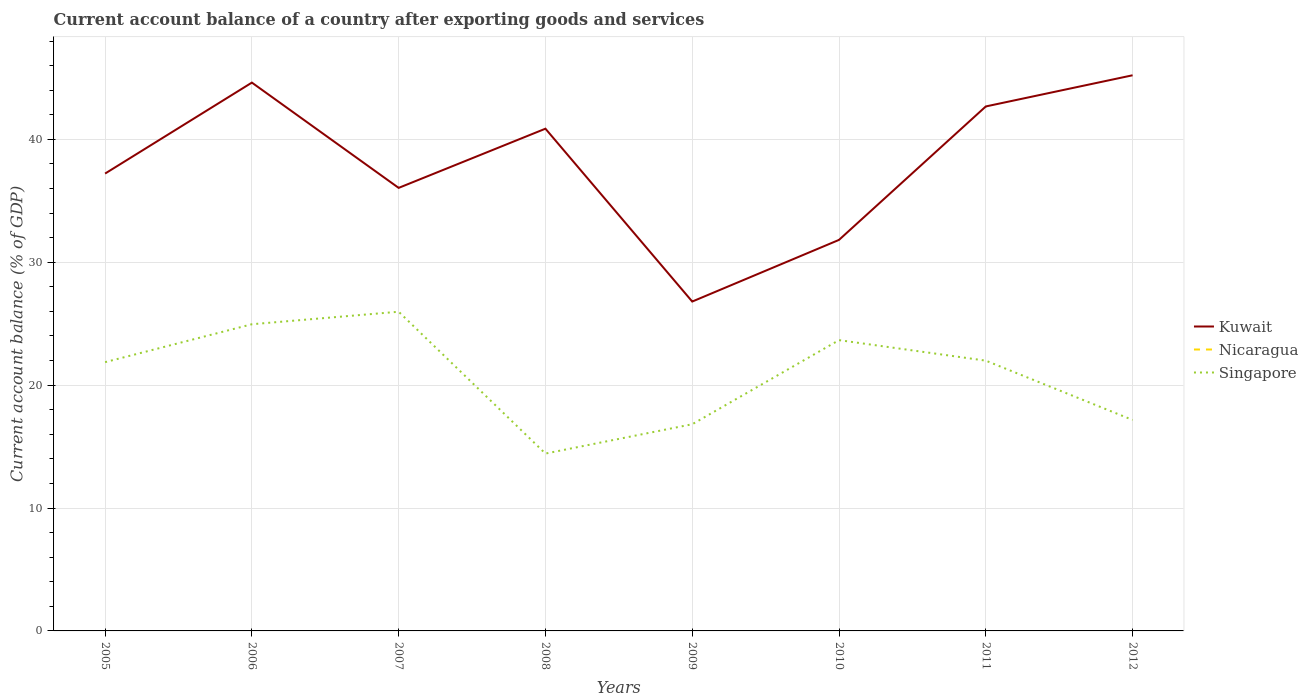How many different coloured lines are there?
Your response must be concise. 2. Does the line corresponding to Kuwait intersect with the line corresponding to Singapore?
Your answer should be very brief. No. Across all years, what is the maximum account balance in Singapore?
Provide a short and direct response. 14.43. What is the total account balance in Kuwait in the graph?
Your answer should be compact. -7.4. What is the difference between the highest and the second highest account balance in Singapore?
Give a very brief answer. 11.54. What is the difference between the highest and the lowest account balance in Kuwait?
Provide a succinct answer. 4. Does the graph contain grids?
Your answer should be compact. Yes. Where does the legend appear in the graph?
Offer a terse response. Center right. How many legend labels are there?
Provide a short and direct response. 3. What is the title of the graph?
Make the answer very short. Current account balance of a country after exporting goods and services. Does "Least developed countries" appear as one of the legend labels in the graph?
Provide a short and direct response. No. What is the label or title of the X-axis?
Your answer should be very brief. Years. What is the label or title of the Y-axis?
Make the answer very short. Current account balance (% of GDP). What is the Current account balance (% of GDP) in Kuwait in 2005?
Provide a succinct answer. 37.22. What is the Current account balance (% of GDP) in Nicaragua in 2005?
Give a very brief answer. 0. What is the Current account balance (% of GDP) of Singapore in 2005?
Offer a very short reply. 21.87. What is the Current account balance (% of GDP) of Kuwait in 2006?
Offer a terse response. 44.62. What is the Current account balance (% of GDP) of Singapore in 2006?
Offer a very short reply. 24.96. What is the Current account balance (% of GDP) in Kuwait in 2007?
Offer a terse response. 36.05. What is the Current account balance (% of GDP) in Singapore in 2007?
Your answer should be very brief. 25.97. What is the Current account balance (% of GDP) in Kuwait in 2008?
Keep it short and to the point. 40.87. What is the Current account balance (% of GDP) in Nicaragua in 2008?
Make the answer very short. 0. What is the Current account balance (% of GDP) in Singapore in 2008?
Ensure brevity in your answer.  14.43. What is the Current account balance (% of GDP) in Kuwait in 2009?
Provide a short and direct response. 26.8. What is the Current account balance (% of GDP) in Nicaragua in 2009?
Keep it short and to the point. 0. What is the Current account balance (% of GDP) in Singapore in 2009?
Ensure brevity in your answer.  16.82. What is the Current account balance (% of GDP) of Kuwait in 2010?
Your response must be concise. 31.82. What is the Current account balance (% of GDP) in Singapore in 2010?
Give a very brief answer. 23.66. What is the Current account balance (% of GDP) in Kuwait in 2011?
Your response must be concise. 42.68. What is the Current account balance (% of GDP) in Singapore in 2011?
Offer a terse response. 21.99. What is the Current account balance (% of GDP) in Kuwait in 2012?
Your response must be concise. 45.22. What is the Current account balance (% of GDP) in Nicaragua in 2012?
Keep it short and to the point. 0. What is the Current account balance (% of GDP) of Singapore in 2012?
Provide a succinct answer. 17.17. Across all years, what is the maximum Current account balance (% of GDP) of Kuwait?
Provide a short and direct response. 45.22. Across all years, what is the maximum Current account balance (% of GDP) in Singapore?
Make the answer very short. 25.97. Across all years, what is the minimum Current account balance (% of GDP) of Kuwait?
Offer a very short reply. 26.8. Across all years, what is the minimum Current account balance (% of GDP) in Singapore?
Provide a short and direct response. 14.43. What is the total Current account balance (% of GDP) in Kuwait in the graph?
Your answer should be compact. 305.28. What is the total Current account balance (% of GDP) in Singapore in the graph?
Your answer should be compact. 166.87. What is the difference between the Current account balance (% of GDP) of Kuwait in 2005 and that in 2006?
Make the answer very short. -7.4. What is the difference between the Current account balance (% of GDP) of Singapore in 2005 and that in 2006?
Your answer should be compact. -3.08. What is the difference between the Current account balance (% of GDP) of Kuwait in 2005 and that in 2007?
Make the answer very short. 1.17. What is the difference between the Current account balance (% of GDP) of Singapore in 2005 and that in 2007?
Offer a very short reply. -4.1. What is the difference between the Current account balance (% of GDP) of Kuwait in 2005 and that in 2008?
Your response must be concise. -3.65. What is the difference between the Current account balance (% of GDP) in Singapore in 2005 and that in 2008?
Keep it short and to the point. 7.44. What is the difference between the Current account balance (% of GDP) in Kuwait in 2005 and that in 2009?
Offer a very short reply. 10.41. What is the difference between the Current account balance (% of GDP) of Singapore in 2005 and that in 2009?
Make the answer very short. 5.05. What is the difference between the Current account balance (% of GDP) of Kuwait in 2005 and that in 2010?
Offer a terse response. 5.4. What is the difference between the Current account balance (% of GDP) of Singapore in 2005 and that in 2010?
Keep it short and to the point. -1.79. What is the difference between the Current account balance (% of GDP) in Kuwait in 2005 and that in 2011?
Your response must be concise. -5.46. What is the difference between the Current account balance (% of GDP) in Singapore in 2005 and that in 2011?
Give a very brief answer. -0.12. What is the difference between the Current account balance (% of GDP) in Kuwait in 2005 and that in 2012?
Give a very brief answer. -8. What is the difference between the Current account balance (% of GDP) in Singapore in 2005 and that in 2012?
Your answer should be very brief. 4.7. What is the difference between the Current account balance (% of GDP) of Kuwait in 2006 and that in 2007?
Provide a short and direct response. 8.57. What is the difference between the Current account balance (% of GDP) in Singapore in 2006 and that in 2007?
Offer a terse response. -1.02. What is the difference between the Current account balance (% of GDP) of Kuwait in 2006 and that in 2008?
Ensure brevity in your answer.  3.75. What is the difference between the Current account balance (% of GDP) in Singapore in 2006 and that in 2008?
Your answer should be very brief. 10.52. What is the difference between the Current account balance (% of GDP) of Kuwait in 2006 and that in 2009?
Offer a very short reply. 17.82. What is the difference between the Current account balance (% of GDP) of Singapore in 2006 and that in 2009?
Your answer should be very brief. 8.14. What is the difference between the Current account balance (% of GDP) of Kuwait in 2006 and that in 2010?
Your answer should be very brief. 12.8. What is the difference between the Current account balance (% of GDP) in Singapore in 2006 and that in 2010?
Keep it short and to the point. 1.29. What is the difference between the Current account balance (% of GDP) of Kuwait in 2006 and that in 2011?
Offer a terse response. 1.94. What is the difference between the Current account balance (% of GDP) in Singapore in 2006 and that in 2011?
Ensure brevity in your answer.  2.96. What is the difference between the Current account balance (% of GDP) of Kuwait in 2006 and that in 2012?
Offer a terse response. -0.6. What is the difference between the Current account balance (% of GDP) of Singapore in 2006 and that in 2012?
Give a very brief answer. 7.79. What is the difference between the Current account balance (% of GDP) of Kuwait in 2007 and that in 2008?
Provide a succinct answer. -4.82. What is the difference between the Current account balance (% of GDP) in Singapore in 2007 and that in 2008?
Your answer should be very brief. 11.54. What is the difference between the Current account balance (% of GDP) in Kuwait in 2007 and that in 2009?
Make the answer very short. 9.25. What is the difference between the Current account balance (% of GDP) of Singapore in 2007 and that in 2009?
Offer a very short reply. 9.16. What is the difference between the Current account balance (% of GDP) in Kuwait in 2007 and that in 2010?
Make the answer very short. 4.23. What is the difference between the Current account balance (% of GDP) of Singapore in 2007 and that in 2010?
Give a very brief answer. 2.31. What is the difference between the Current account balance (% of GDP) in Kuwait in 2007 and that in 2011?
Provide a succinct answer. -6.63. What is the difference between the Current account balance (% of GDP) of Singapore in 2007 and that in 2011?
Your answer should be very brief. 3.98. What is the difference between the Current account balance (% of GDP) of Kuwait in 2007 and that in 2012?
Your answer should be compact. -9.16. What is the difference between the Current account balance (% of GDP) of Singapore in 2007 and that in 2012?
Offer a very short reply. 8.81. What is the difference between the Current account balance (% of GDP) in Kuwait in 2008 and that in 2009?
Keep it short and to the point. 14.07. What is the difference between the Current account balance (% of GDP) in Singapore in 2008 and that in 2009?
Your response must be concise. -2.39. What is the difference between the Current account balance (% of GDP) in Kuwait in 2008 and that in 2010?
Your response must be concise. 9.05. What is the difference between the Current account balance (% of GDP) of Singapore in 2008 and that in 2010?
Ensure brevity in your answer.  -9.23. What is the difference between the Current account balance (% of GDP) of Kuwait in 2008 and that in 2011?
Your answer should be very brief. -1.81. What is the difference between the Current account balance (% of GDP) in Singapore in 2008 and that in 2011?
Make the answer very short. -7.56. What is the difference between the Current account balance (% of GDP) in Kuwait in 2008 and that in 2012?
Offer a very short reply. -4.35. What is the difference between the Current account balance (% of GDP) in Singapore in 2008 and that in 2012?
Offer a terse response. -2.73. What is the difference between the Current account balance (% of GDP) in Kuwait in 2009 and that in 2010?
Provide a short and direct response. -5.02. What is the difference between the Current account balance (% of GDP) in Singapore in 2009 and that in 2010?
Your answer should be compact. -6.84. What is the difference between the Current account balance (% of GDP) of Kuwait in 2009 and that in 2011?
Ensure brevity in your answer.  -15.88. What is the difference between the Current account balance (% of GDP) of Singapore in 2009 and that in 2011?
Give a very brief answer. -5.17. What is the difference between the Current account balance (% of GDP) in Kuwait in 2009 and that in 2012?
Make the answer very short. -18.41. What is the difference between the Current account balance (% of GDP) of Singapore in 2009 and that in 2012?
Ensure brevity in your answer.  -0.35. What is the difference between the Current account balance (% of GDP) in Kuwait in 2010 and that in 2011?
Ensure brevity in your answer.  -10.86. What is the difference between the Current account balance (% of GDP) in Singapore in 2010 and that in 2011?
Offer a very short reply. 1.67. What is the difference between the Current account balance (% of GDP) of Kuwait in 2010 and that in 2012?
Provide a short and direct response. -13.4. What is the difference between the Current account balance (% of GDP) of Singapore in 2010 and that in 2012?
Ensure brevity in your answer.  6.5. What is the difference between the Current account balance (% of GDP) of Kuwait in 2011 and that in 2012?
Your answer should be very brief. -2.54. What is the difference between the Current account balance (% of GDP) in Singapore in 2011 and that in 2012?
Keep it short and to the point. 4.83. What is the difference between the Current account balance (% of GDP) in Kuwait in 2005 and the Current account balance (% of GDP) in Singapore in 2006?
Your response must be concise. 12.26. What is the difference between the Current account balance (% of GDP) in Kuwait in 2005 and the Current account balance (% of GDP) in Singapore in 2007?
Make the answer very short. 11.24. What is the difference between the Current account balance (% of GDP) of Kuwait in 2005 and the Current account balance (% of GDP) of Singapore in 2008?
Offer a very short reply. 22.78. What is the difference between the Current account balance (% of GDP) in Kuwait in 2005 and the Current account balance (% of GDP) in Singapore in 2009?
Offer a very short reply. 20.4. What is the difference between the Current account balance (% of GDP) in Kuwait in 2005 and the Current account balance (% of GDP) in Singapore in 2010?
Your answer should be very brief. 13.55. What is the difference between the Current account balance (% of GDP) in Kuwait in 2005 and the Current account balance (% of GDP) in Singapore in 2011?
Your answer should be very brief. 15.22. What is the difference between the Current account balance (% of GDP) of Kuwait in 2005 and the Current account balance (% of GDP) of Singapore in 2012?
Ensure brevity in your answer.  20.05. What is the difference between the Current account balance (% of GDP) of Kuwait in 2006 and the Current account balance (% of GDP) of Singapore in 2007?
Your answer should be compact. 18.65. What is the difference between the Current account balance (% of GDP) in Kuwait in 2006 and the Current account balance (% of GDP) in Singapore in 2008?
Offer a terse response. 30.19. What is the difference between the Current account balance (% of GDP) of Kuwait in 2006 and the Current account balance (% of GDP) of Singapore in 2009?
Give a very brief answer. 27.8. What is the difference between the Current account balance (% of GDP) of Kuwait in 2006 and the Current account balance (% of GDP) of Singapore in 2010?
Offer a very short reply. 20.96. What is the difference between the Current account balance (% of GDP) of Kuwait in 2006 and the Current account balance (% of GDP) of Singapore in 2011?
Provide a succinct answer. 22.63. What is the difference between the Current account balance (% of GDP) of Kuwait in 2006 and the Current account balance (% of GDP) of Singapore in 2012?
Give a very brief answer. 27.45. What is the difference between the Current account balance (% of GDP) in Kuwait in 2007 and the Current account balance (% of GDP) in Singapore in 2008?
Make the answer very short. 21.62. What is the difference between the Current account balance (% of GDP) of Kuwait in 2007 and the Current account balance (% of GDP) of Singapore in 2009?
Keep it short and to the point. 19.23. What is the difference between the Current account balance (% of GDP) of Kuwait in 2007 and the Current account balance (% of GDP) of Singapore in 2010?
Provide a succinct answer. 12.39. What is the difference between the Current account balance (% of GDP) of Kuwait in 2007 and the Current account balance (% of GDP) of Singapore in 2011?
Provide a short and direct response. 14.06. What is the difference between the Current account balance (% of GDP) of Kuwait in 2007 and the Current account balance (% of GDP) of Singapore in 2012?
Give a very brief answer. 18.88. What is the difference between the Current account balance (% of GDP) of Kuwait in 2008 and the Current account balance (% of GDP) of Singapore in 2009?
Your response must be concise. 24.05. What is the difference between the Current account balance (% of GDP) in Kuwait in 2008 and the Current account balance (% of GDP) in Singapore in 2010?
Your answer should be very brief. 17.21. What is the difference between the Current account balance (% of GDP) of Kuwait in 2008 and the Current account balance (% of GDP) of Singapore in 2011?
Offer a terse response. 18.88. What is the difference between the Current account balance (% of GDP) of Kuwait in 2008 and the Current account balance (% of GDP) of Singapore in 2012?
Provide a succinct answer. 23.7. What is the difference between the Current account balance (% of GDP) of Kuwait in 2009 and the Current account balance (% of GDP) of Singapore in 2010?
Provide a short and direct response. 3.14. What is the difference between the Current account balance (% of GDP) of Kuwait in 2009 and the Current account balance (% of GDP) of Singapore in 2011?
Provide a short and direct response. 4.81. What is the difference between the Current account balance (% of GDP) in Kuwait in 2009 and the Current account balance (% of GDP) in Singapore in 2012?
Your response must be concise. 9.64. What is the difference between the Current account balance (% of GDP) in Kuwait in 2010 and the Current account balance (% of GDP) in Singapore in 2011?
Your response must be concise. 9.83. What is the difference between the Current account balance (% of GDP) in Kuwait in 2010 and the Current account balance (% of GDP) in Singapore in 2012?
Your response must be concise. 14.65. What is the difference between the Current account balance (% of GDP) of Kuwait in 2011 and the Current account balance (% of GDP) of Singapore in 2012?
Make the answer very short. 25.51. What is the average Current account balance (% of GDP) in Kuwait per year?
Your response must be concise. 38.16. What is the average Current account balance (% of GDP) in Singapore per year?
Provide a succinct answer. 20.86. In the year 2005, what is the difference between the Current account balance (% of GDP) in Kuwait and Current account balance (% of GDP) in Singapore?
Provide a short and direct response. 15.35. In the year 2006, what is the difference between the Current account balance (% of GDP) of Kuwait and Current account balance (% of GDP) of Singapore?
Offer a very short reply. 19.66. In the year 2007, what is the difference between the Current account balance (% of GDP) in Kuwait and Current account balance (% of GDP) in Singapore?
Keep it short and to the point. 10.08. In the year 2008, what is the difference between the Current account balance (% of GDP) in Kuwait and Current account balance (% of GDP) in Singapore?
Give a very brief answer. 26.44. In the year 2009, what is the difference between the Current account balance (% of GDP) in Kuwait and Current account balance (% of GDP) in Singapore?
Your response must be concise. 9.98. In the year 2010, what is the difference between the Current account balance (% of GDP) in Kuwait and Current account balance (% of GDP) in Singapore?
Ensure brevity in your answer.  8.16. In the year 2011, what is the difference between the Current account balance (% of GDP) of Kuwait and Current account balance (% of GDP) of Singapore?
Ensure brevity in your answer.  20.69. In the year 2012, what is the difference between the Current account balance (% of GDP) in Kuwait and Current account balance (% of GDP) in Singapore?
Provide a succinct answer. 28.05. What is the ratio of the Current account balance (% of GDP) of Kuwait in 2005 to that in 2006?
Your answer should be very brief. 0.83. What is the ratio of the Current account balance (% of GDP) of Singapore in 2005 to that in 2006?
Make the answer very short. 0.88. What is the ratio of the Current account balance (% of GDP) of Kuwait in 2005 to that in 2007?
Your answer should be compact. 1.03. What is the ratio of the Current account balance (% of GDP) of Singapore in 2005 to that in 2007?
Offer a very short reply. 0.84. What is the ratio of the Current account balance (% of GDP) in Kuwait in 2005 to that in 2008?
Offer a terse response. 0.91. What is the ratio of the Current account balance (% of GDP) in Singapore in 2005 to that in 2008?
Give a very brief answer. 1.52. What is the ratio of the Current account balance (% of GDP) in Kuwait in 2005 to that in 2009?
Make the answer very short. 1.39. What is the ratio of the Current account balance (% of GDP) in Singapore in 2005 to that in 2009?
Provide a short and direct response. 1.3. What is the ratio of the Current account balance (% of GDP) in Kuwait in 2005 to that in 2010?
Make the answer very short. 1.17. What is the ratio of the Current account balance (% of GDP) in Singapore in 2005 to that in 2010?
Ensure brevity in your answer.  0.92. What is the ratio of the Current account balance (% of GDP) in Kuwait in 2005 to that in 2011?
Keep it short and to the point. 0.87. What is the ratio of the Current account balance (% of GDP) in Kuwait in 2005 to that in 2012?
Offer a terse response. 0.82. What is the ratio of the Current account balance (% of GDP) in Singapore in 2005 to that in 2012?
Your response must be concise. 1.27. What is the ratio of the Current account balance (% of GDP) in Kuwait in 2006 to that in 2007?
Keep it short and to the point. 1.24. What is the ratio of the Current account balance (% of GDP) in Singapore in 2006 to that in 2007?
Offer a terse response. 0.96. What is the ratio of the Current account balance (% of GDP) of Kuwait in 2006 to that in 2008?
Offer a very short reply. 1.09. What is the ratio of the Current account balance (% of GDP) of Singapore in 2006 to that in 2008?
Ensure brevity in your answer.  1.73. What is the ratio of the Current account balance (% of GDP) in Kuwait in 2006 to that in 2009?
Offer a terse response. 1.66. What is the ratio of the Current account balance (% of GDP) in Singapore in 2006 to that in 2009?
Offer a terse response. 1.48. What is the ratio of the Current account balance (% of GDP) in Kuwait in 2006 to that in 2010?
Your answer should be compact. 1.4. What is the ratio of the Current account balance (% of GDP) of Singapore in 2006 to that in 2010?
Provide a succinct answer. 1.05. What is the ratio of the Current account balance (% of GDP) in Kuwait in 2006 to that in 2011?
Your answer should be compact. 1.05. What is the ratio of the Current account balance (% of GDP) in Singapore in 2006 to that in 2011?
Make the answer very short. 1.13. What is the ratio of the Current account balance (% of GDP) of Singapore in 2006 to that in 2012?
Your answer should be compact. 1.45. What is the ratio of the Current account balance (% of GDP) of Kuwait in 2007 to that in 2008?
Give a very brief answer. 0.88. What is the ratio of the Current account balance (% of GDP) of Singapore in 2007 to that in 2008?
Your response must be concise. 1.8. What is the ratio of the Current account balance (% of GDP) of Kuwait in 2007 to that in 2009?
Keep it short and to the point. 1.35. What is the ratio of the Current account balance (% of GDP) in Singapore in 2007 to that in 2009?
Ensure brevity in your answer.  1.54. What is the ratio of the Current account balance (% of GDP) in Kuwait in 2007 to that in 2010?
Provide a short and direct response. 1.13. What is the ratio of the Current account balance (% of GDP) of Singapore in 2007 to that in 2010?
Keep it short and to the point. 1.1. What is the ratio of the Current account balance (% of GDP) of Kuwait in 2007 to that in 2011?
Give a very brief answer. 0.84. What is the ratio of the Current account balance (% of GDP) in Singapore in 2007 to that in 2011?
Offer a very short reply. 1.18. What is the ratio of the Current account balance (% of GDP) of Kuwait in 2007 to that in 2012?
Ensure brevity in your answer.  0.8. What is the ratio of the Current account balance (% of GDP) of Singapore in 2007 to that in 2012?
Your response must be concise. 1.51. What is the ratio of the Current account balance (% of GDP) of Kuwait in 2008 to that in 2009?
Your answer should be compact. 1.52. What is the ratio of the Current account balance (% of GDP) of Singapore in 2008 to that in 2009?
Your answer should be very brief. 0.86. What is the ratio of the Current account balance (% of GDP) in Kuwait in 2008 to that in 2010?
Your response must be concise. 1.28. What is the ratio of the Current account balance (% of GDP) of Singapore in 2008 to that in 2010?
Give a very brief answer. 0.61. What is the ratio of the Current account balance (% of GDP) in Kuwait in 2008 to that in 2011?
Your response must be concise. 0.96. What is the ratio of the Current account balance (% of GDP) in Singapore in 2008 to that in 2011?
Offer a very short reply. 0.66. What is the ratio of the Current account balance (% of GDP) in Kuwait in 2008 to that in 2012?
Your response must be concise. 0.9. What is the ratio of the Current account balance (% of GDP) in Singapore in 2008 to that in 2012?
Offer a very short reply. 0.84. What is the ratio of the Current account balance (% of GDP) in Kuwait in 2009 to that in 2010?
Keep it short and to the point. 0.84. What is the ratio of the Current account balance (% of GDP) in Singapore in 2009 to that in 2010?
Your answer should be compact. 0.71. What is the ratio of the Current account balance (% of GDP) in Kuwait in 2009 to that in 2011?
Your response must be concise. 0.63. What is the ratio of the Current account balance (% of GDP) in Singapore in 2009 to that in 2011?
Offer a terse response. 0.76. What is the ratio of the Current account balance (% of GDP) of Kuwait in 2009 to that in 2012?
Keep it short and to the point. 0.59. What is the ratio of the Current account balance (% of GDP) in Singapore in 2009 to that in 2012?
Your answer should be very brief. 0.98. What is the ratio of the Current account balance (% of GDP) in Kuwait in 2010 to that in 2011?
Offer a terse response. 0.75. What is the ratio of the Current account balance (% of GDP) of Singapore in 2010 to that in 2011?
Offer a very short reply. 1.08. What is the ratio of the Current account balance (% of GDP) in Kuwait in 2010 to that in 2012?
Give a very brief answer. 0.7. What is the ratio of the Current account balance (% of GDP) of Singapore in 2010 to that in 2012?
Offer a very short reply. 1.38. What is the ratio of the Current account balance (% of GDP) in Kuwait in 2011 to that in 2012?
Keep it short and to the point. 0.94. What is the ratio of the Current account balance (% of GDP) of Singapore in 2011 to that in 2012?
Keep it short and to the point. 1.28. What is the difference between the highest and the second highest Current account balance (% of GDP) of Kuwait?
Make the answer very short. 0.6. What is the difference between the highest and the second highest Current account balance (% of GDP) in Singapore?
Your response must be concise. 1.02. What is the difference between the highest and the lowest Current account balance (% of GDP) in Kuwait?
Give a very brief answer. 18.41. What is the difference between the highest and the lowest Current account balance (% of GDP) in Singapore?
Keep it short and to the point. 11.54. 